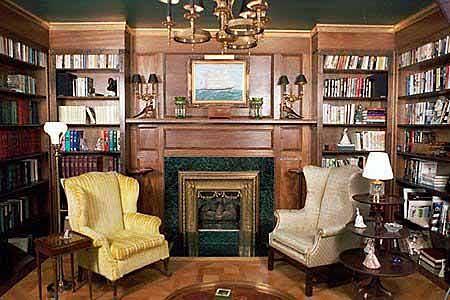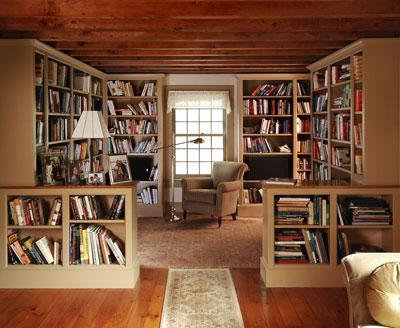The first image is the image on the left, the second image is the image on the right. Considering the images on both sides, is "In one image, bookcases along a wall flank a fireplace, over which hangs one framed picture." valid? Answer yes or no. Yes. 